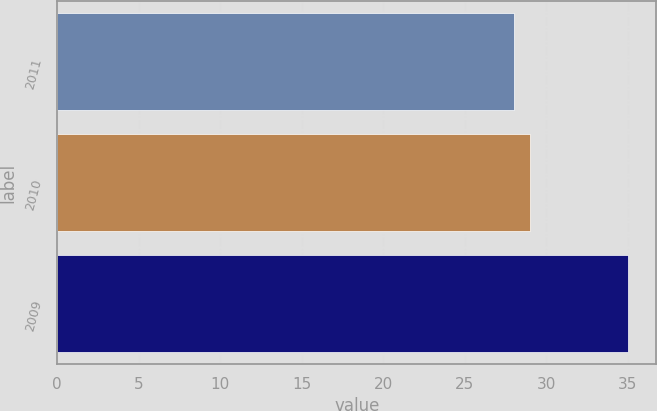<chart> <loc_0><loc_0><loc_500><loc_500><bar_chart><fcel>2011<fcel>2010<fcel>2009<nl><fcel>28<fcel>29<fcel>35<nl></chart> 